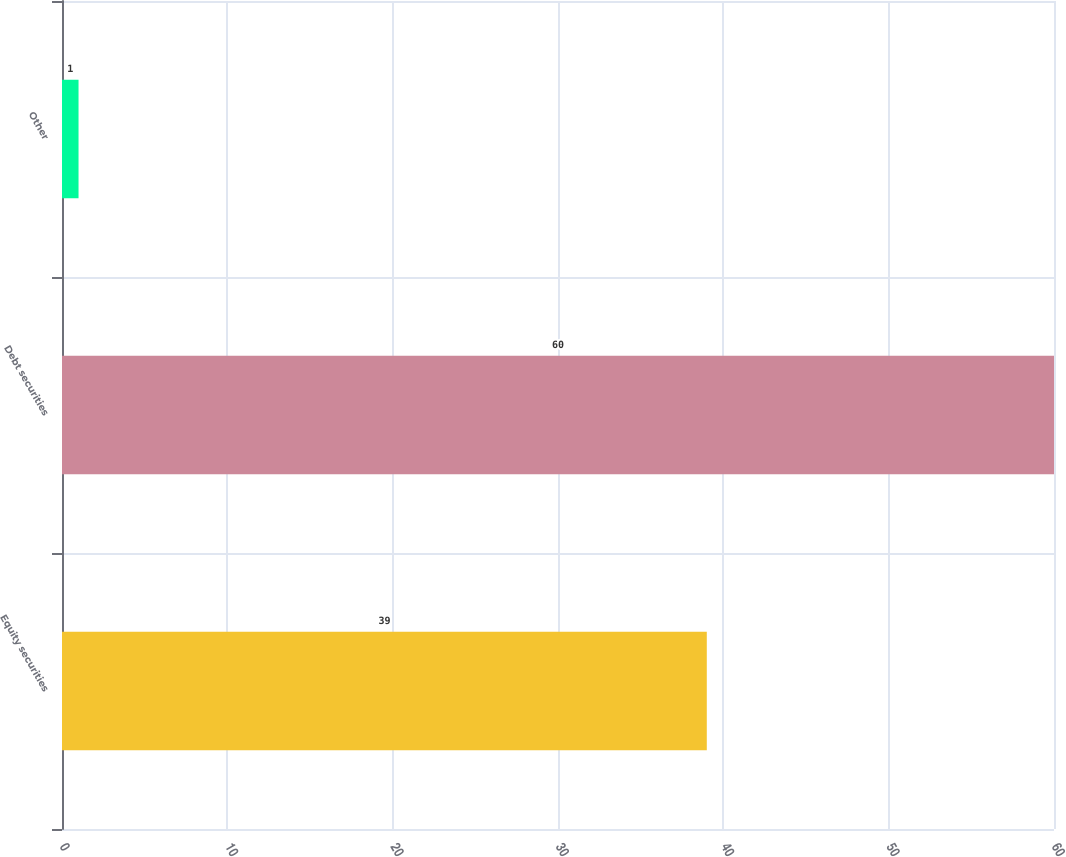Convert chart to OTSL. <chart><loc_0><loc_0><loc_500><loc_500><bar_chart><fcel>Equity securities<fcel>Debt securities<fcel>Other<nl><fcel>39<fcel>60<fcel>1<nl></chart> 